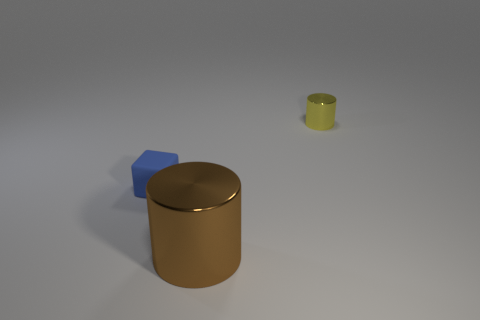How many tiny objects are behind the tiny cube and left of the brown object?
Provide a short and direct response. 0. What material is the tiny cylinder?
Give a very brief answer. Metal. The yellow object that is the same size as the blue matte block is what shape?
Provide a short and direct response. Cylinder. Do the tiny thing to the right of the large brown metal object and the cylinder in front of the yellow cylinder have the same material?
Keep it short and to the point. Yes. What number of small green blocks are there?
Your response must be concise. 0. How many other big brown metallic objects are the same shape as the large brown metallic thing?
Provide a succinct answer. 0. Does the large object have the same shape as the blue thing?
Provide a succinct answer. No. The blue block is what size?
Offer a terse response. Small. How many blue matte cubes are the same size as the brown metallic thing?
Provide a short and direct response. 0. Is the size of the object behind the small blue matte cube the same as the thing to the left of the big shiny cylinder?
Your answer should be compact. Yes. 